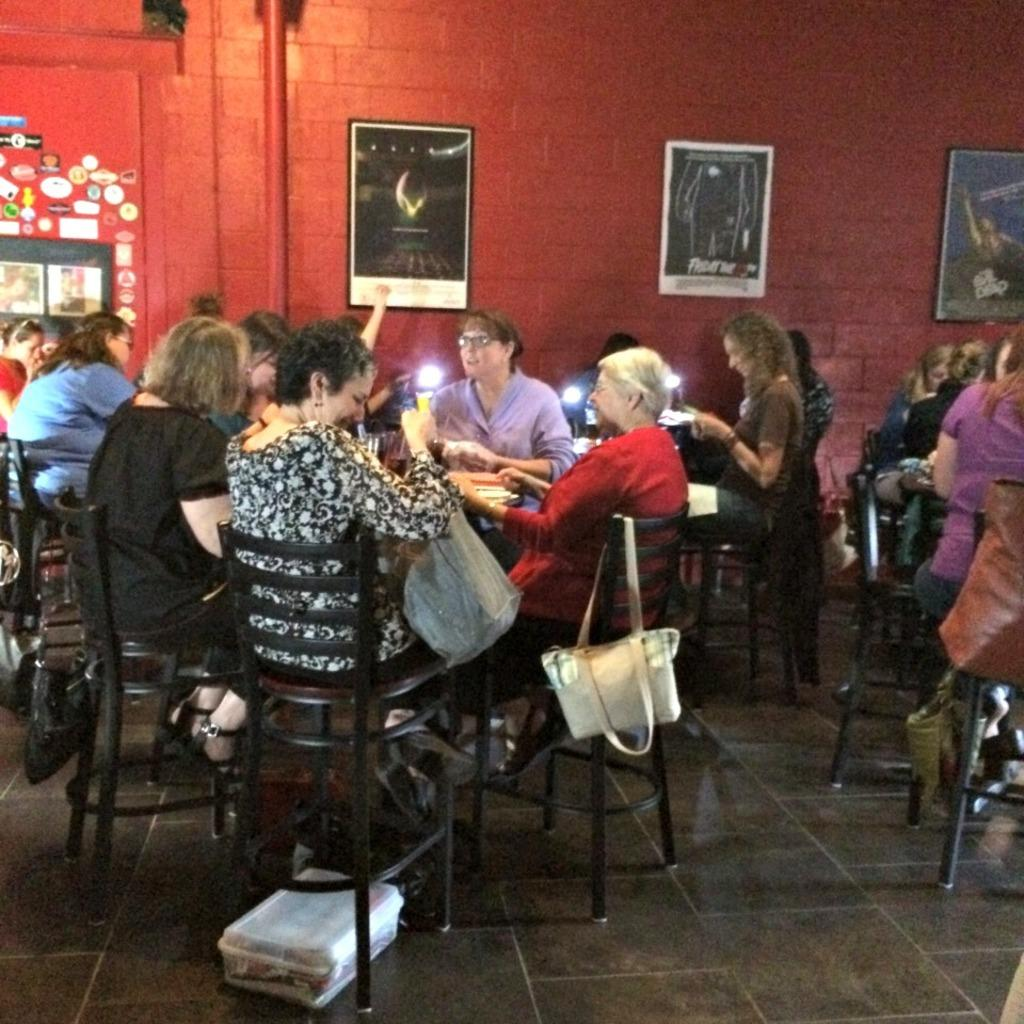What are the people in the image doing? people in the image doing? What can be seen hanging on a chair in the image? A: A white bag is hanging on a chair in the image. What color is the wall in the background of the image? There is a red wall in the background of the image. What is hung on the red wall in the image? Photo frames are hung on the red wall in the image. What type of cord is used to hang the twig on the wall in the image? There is no twig or cord present in the image. 